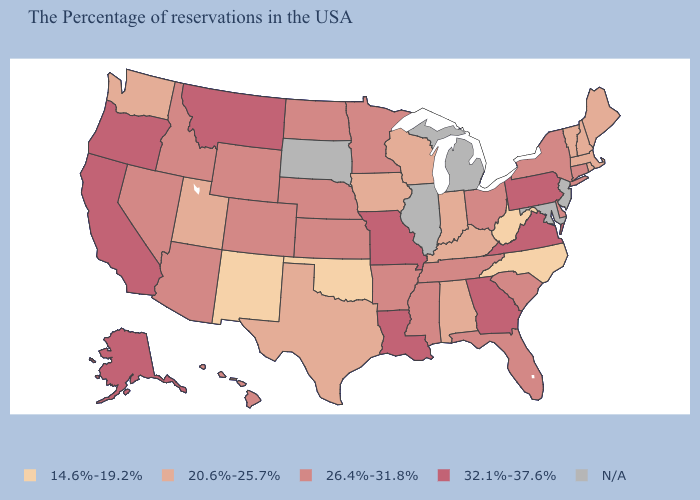How many symbols are there in the legend?
Quick response, please. 5. Does Kansas have the lowest value in the MidWest?
Give a very brief answer. No. Is the legend a continuous bar?
Be succinct. No. What is the highest value in the USA?
Quick response, please. 32.1%-37.6%. What is the value of South Dakota?
Short answer required. N/A. Name the states that have a value in the range 32.1%-37.6%?
Write a very short answer. Pennsylvania, Virginia, Georgia, Louisiana, Missouri, Montana, California, Oregon, Alaska. Among the states that border Mississippi , does Tennessee have the highest value?
Keep it brief. No. Name the states that have a value in the range 20.6%-25.7%?
Give a very brief answer. Maine, Massachusetts, Rhode Island, New Hampshire, Vermont, Kentucky, Indiana, Alabama, Wisconsin, Iowa, Texas, Utah, Washington. What is the lowest value in the Northeast?
Quick response, please. 20.6%-25.7%. What is the value of Arizona?
Write a very short answer. 26.4%-31.8%. Does North Carolina have the lowest value in the USA?
Answer briefly. Yes. Among the states that border Connecticut , does Massachusetts have the highest value?
Be succinct. No. What is the lowest value in the MidWest?
Answer briefly. 20.6%-25.7%. Name the states that have a value in the range 26.4%-31.8%?
Short answer required. Connecticut, New York, Delaware, South Carolina, Ohio, Florida, Tennessee, Mississippi, Arkansas, Minnesota, Kansas, Nebraska, North Dakota, Wyoming, Colorado, Arizona, Idaho, Nevada, Hawaii. Name the states that have a value in the range 32.1%-37.6%?
Short answer required. Pennsylvania, Virginia, Georgia, Louisiana, Missouri, Montana, California, Oregon, Alaska. 